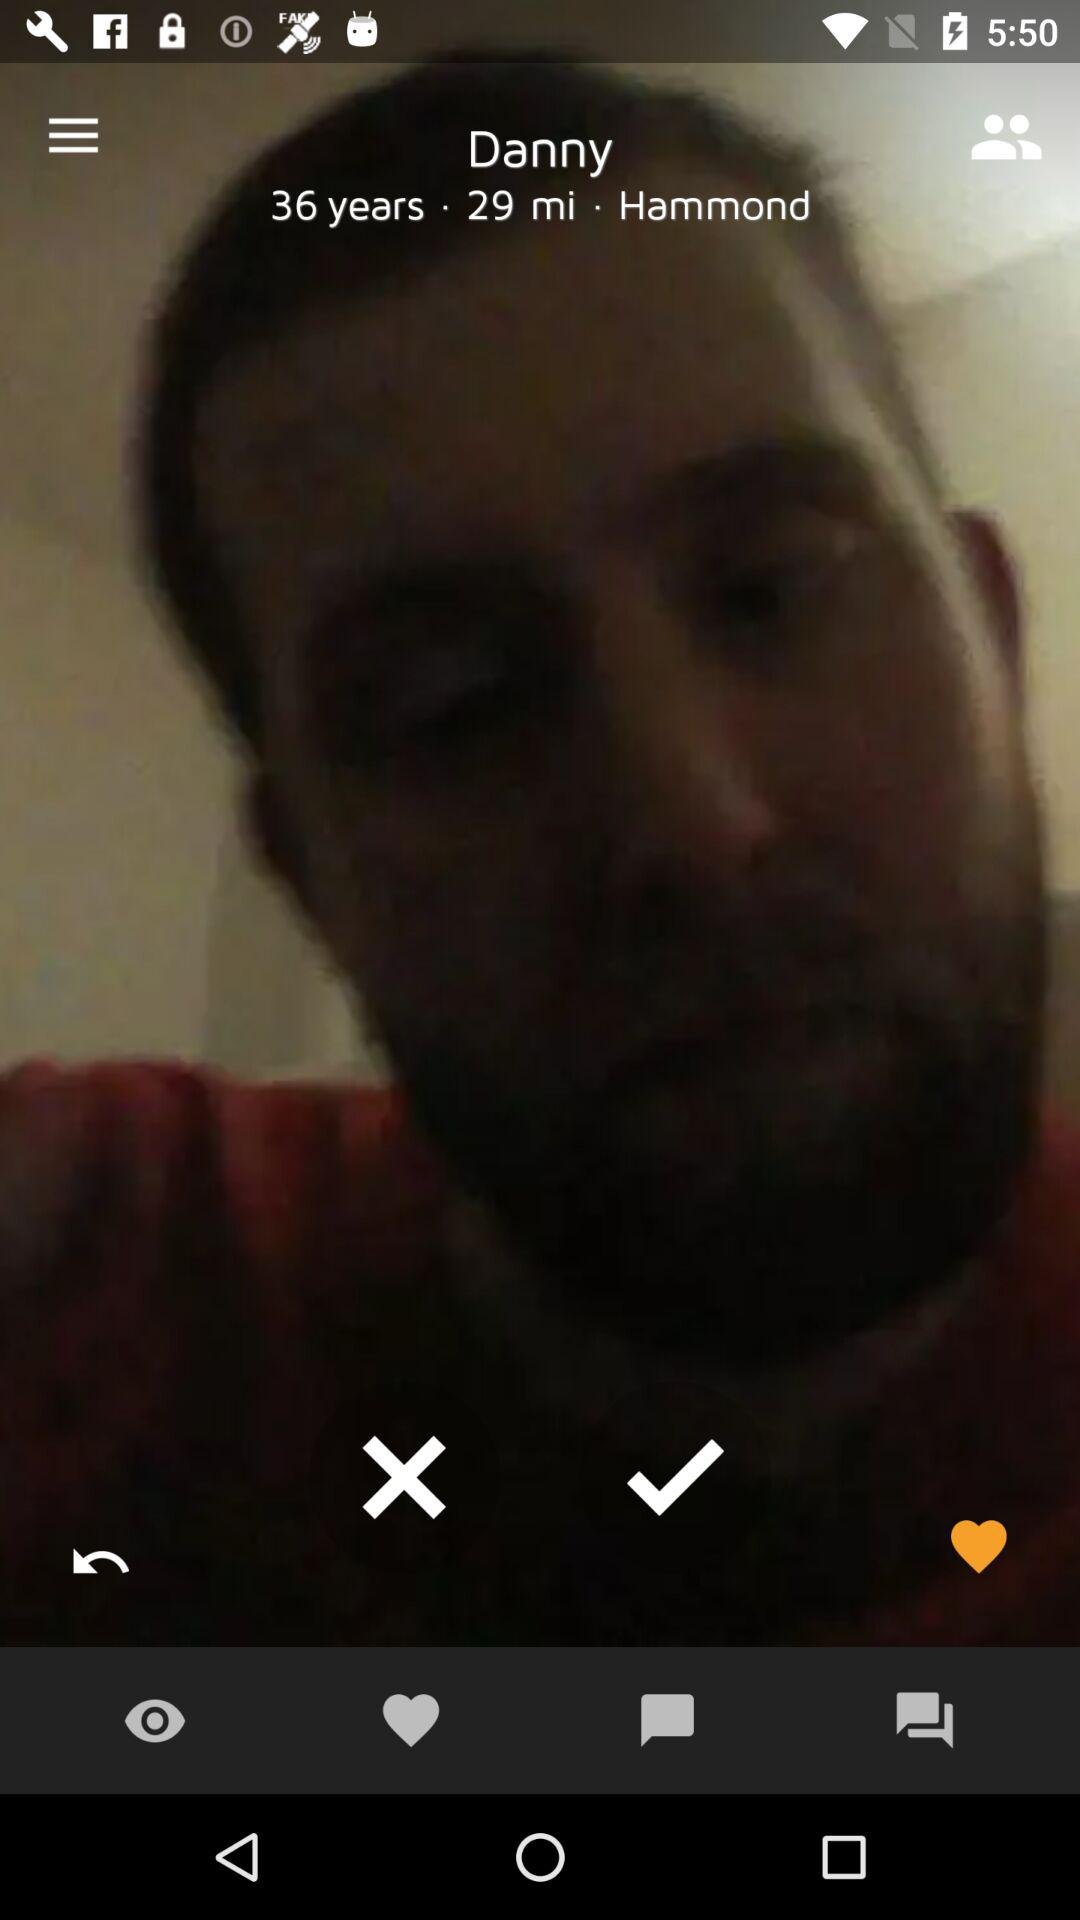How far is it between my location and Danny's? Danny's location is 29 miles from your location. 